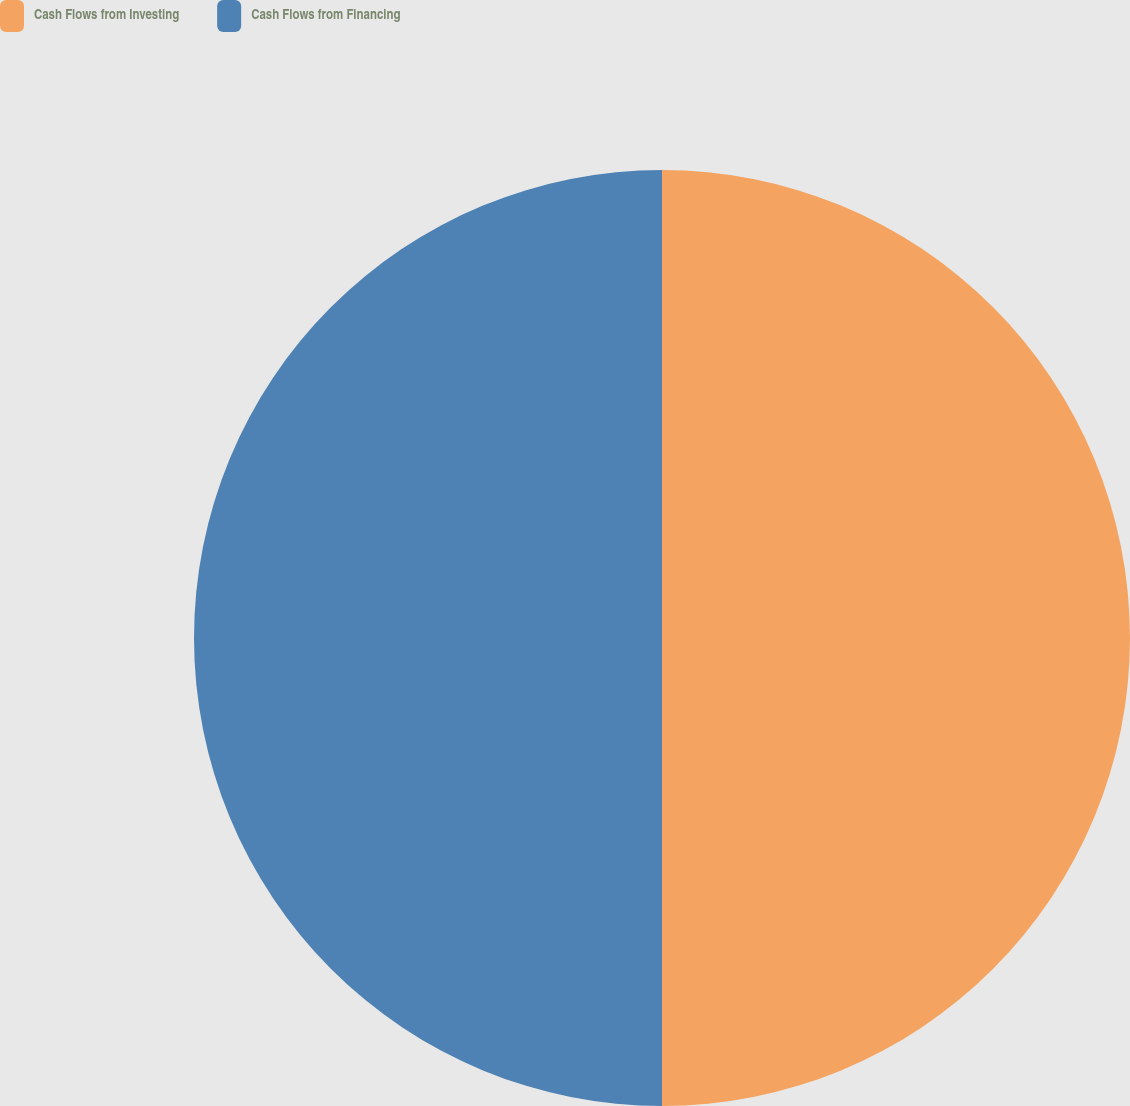Convert chart to OTSL. <chart><loc_0><loc_0><loc_500><loc_500><pie_chart><fcel>Cash Flows from Investing<fcel>Cash Flows from Financing<nl><fcel>50.0%<fcel>50.0%<nl></chart> 